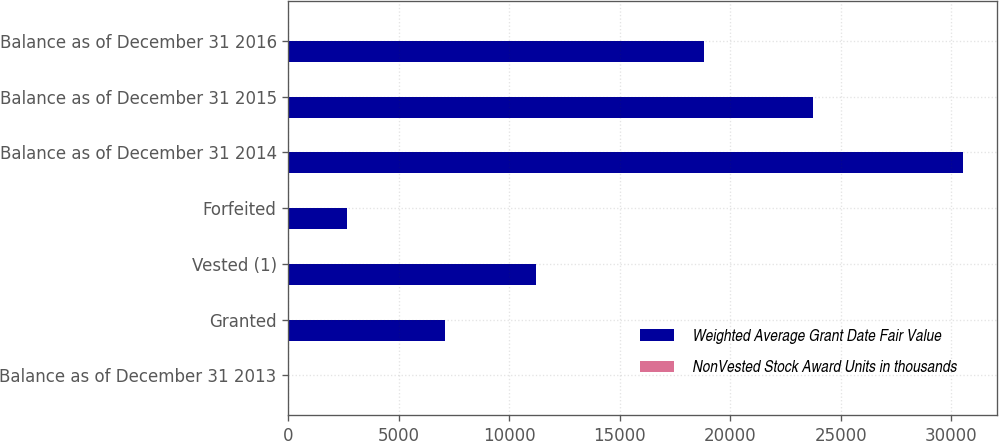Convert chart. <chart><loc_0><loc_0><loc_500><loc_500><stacked_bar_chart><ecel><fcel>Balance as of December 31 2013<fcel>Granted<fcel>Vested (1)<fcel>Forfeited<fcel>Balance as of December 31 2014<fcel>Balance as of December 31 2015<fcel>Balance as of December 31 2016<nl><fcel>Weighted Average Grant Date Fair Value<fcel>14<fcel>7072<fcel>11205<fcel>2671<fcel>30535<fcel>23764<fcel>18797<nl><fcel>NonVested Stock Award Units in thousands<fcel>7<fcel>13<fcel>7<fcel>8<fcel>9<fcel>11<fcel>14<nl></chart> 